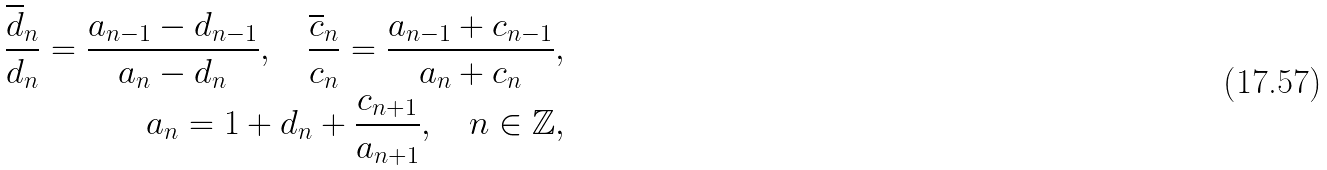Convert formula to latex. <formula><loc_0><loc_0><loc_500><loc_500>\frac { \overline { d } _ { n } } { d _ { n } } = \frac { a _ { n - 1 } - d _ { n - 1 } } { a _ { n } - d _ { n } } , \quad \frac { \overline { c } _ { n } } { c _ { n } } = \frac { a _ { n - 1 } + c _ { n - 1 } } { a _ { n } + c _ { n } } , \\ a _ { n } = 1 + d _ { n } + \frac { c _ { n + 1 } } { a _ { n + 1 } } , \quad n \in \mathbb { Z } ,</formula> 